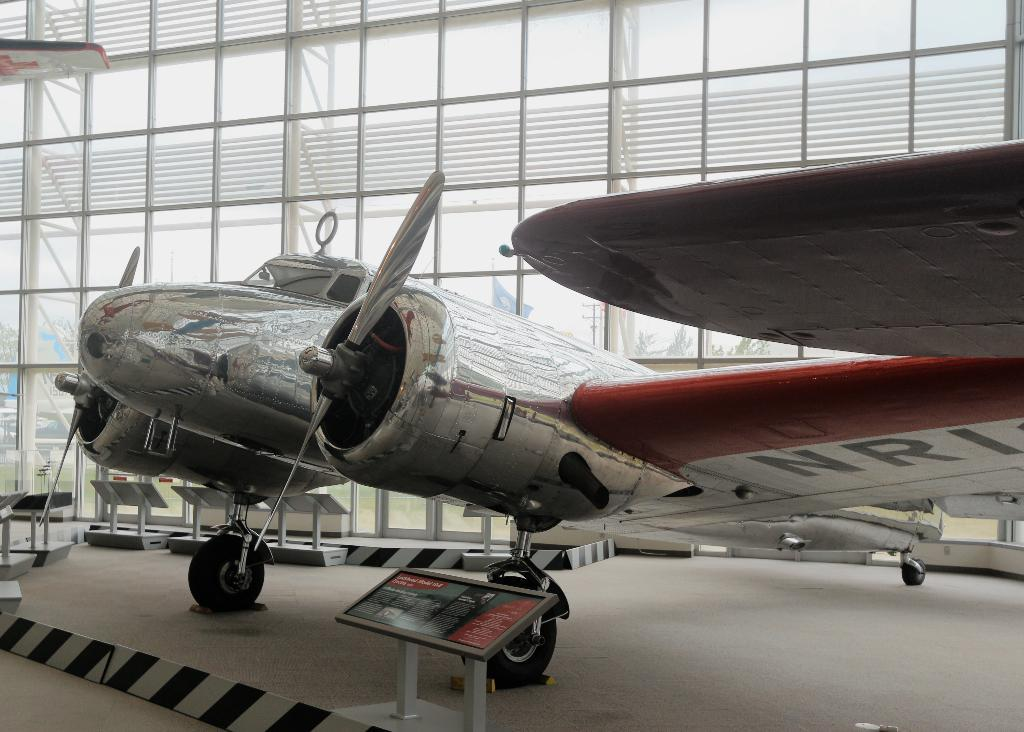<image>
Offer a succinct explanation of the picture presented. A silver aeroplane with the letters NRI on its wing 